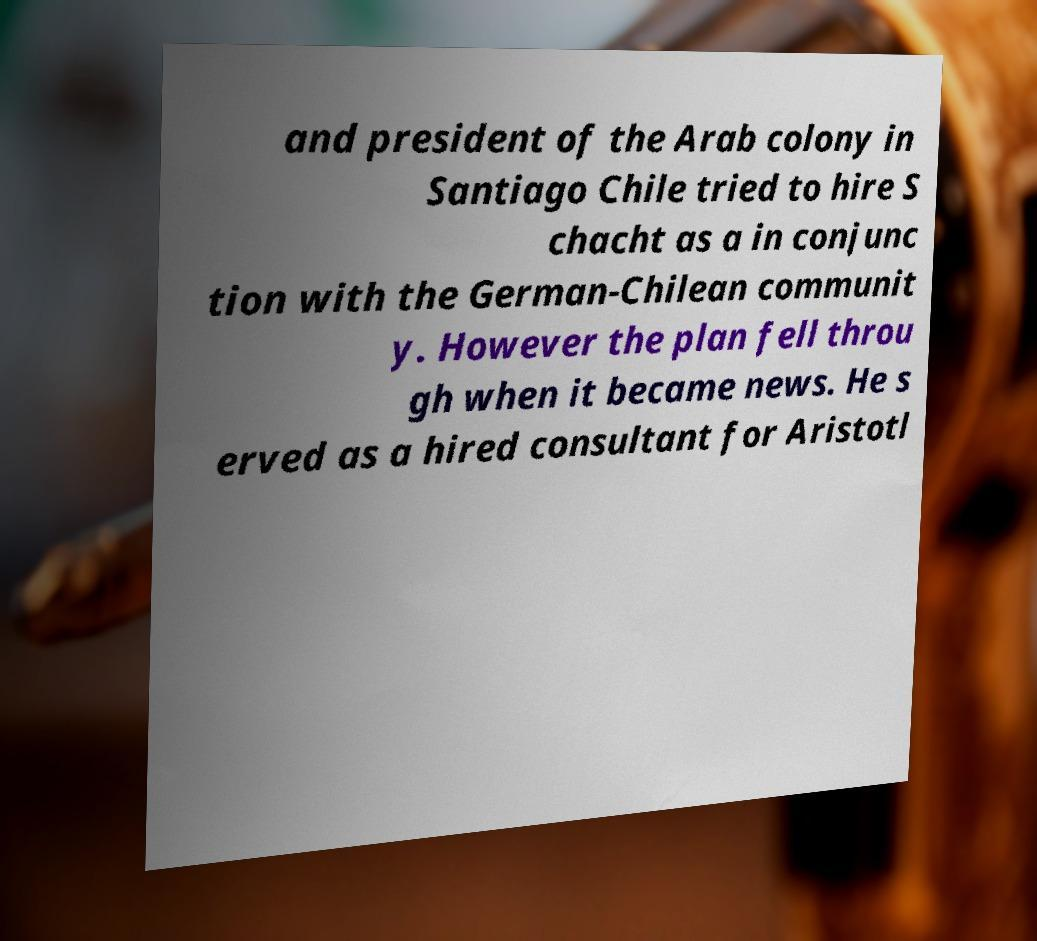Please read and relay the text visible in this image. What does it say? and president of the Arab colony in Santiago Chile tried to hire S chacht as a in conjunc tion with the German-Chilean communit y. However the plan fell throu gh when it became news. He s erved as a hired consultant for Aristotl 